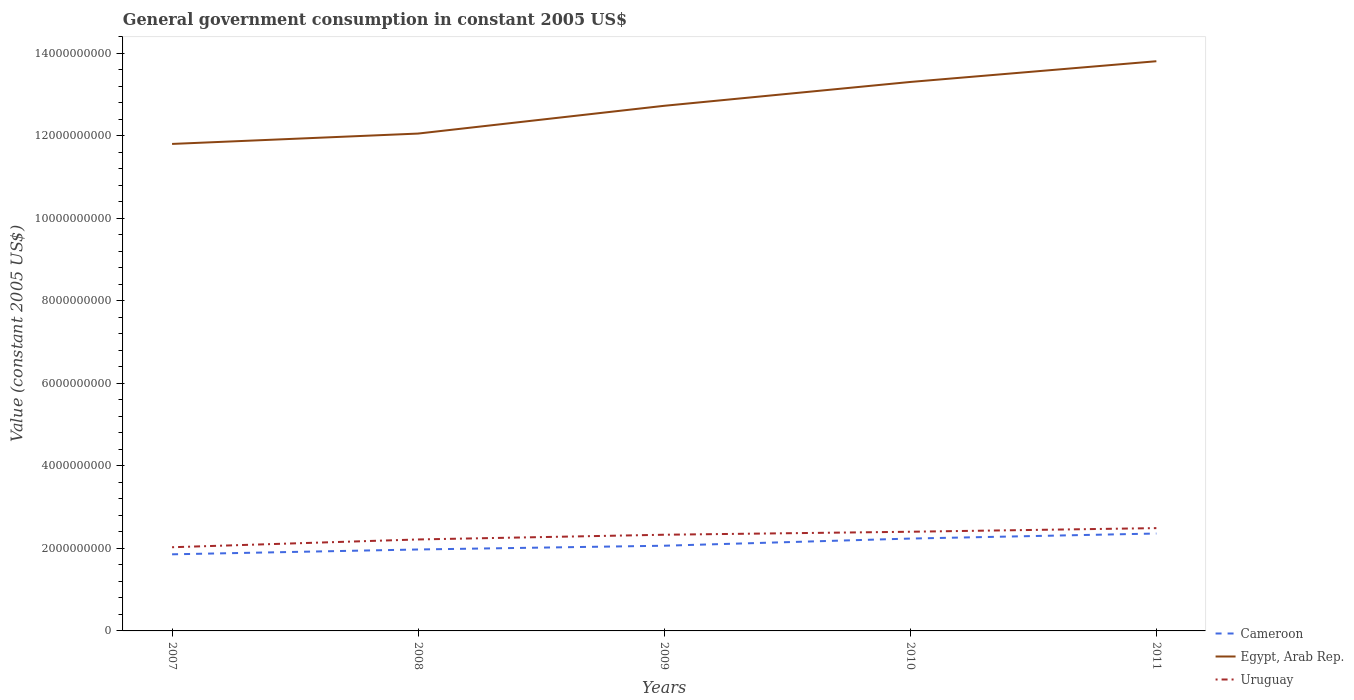Is the number of lines equal to the number of legend labels?
Your answer should be compact. Yes. Across all years, what is the maximum government conusmption in Egypt, Arab Rep.?
Make the answer very short. 1.18e+1. In which year was the government conusmption in Uruguay maximum?
Your answer should be compact. 2007. What is the total government conusmption in Uruguay in the graph?
Your answer should be very brief. -1.60e+08. What is the difference between the highest and the second highest government conusmption in Uruguay?
Make the answer very short. 4.63e+08. What is the difference between the highest and the lowest government conusmption in Uruguay?
Ensure brevity in your answer.  3. Does the graph contain grids?
Provide a short and direct response. No. Where does the legend appear in the graph?
Your response must be concise. Bottom right. What is the title of the graph?
Your answer should be compact. General government consumption in constant 2005 US$. Does "Morocco" appear as one of the legend labels in the graph?
Your answer should be compact. No. What is the label or title of the Y-axis?
Provide a succinct answer. Value (constant 2005 US$). What is the Value (constant 2005 US$) in Cameroon in 2007?
Provide a succinct answer. 1.86e+09. What is the Value (constant 2005 US$) of Egypt, Arab Rep. in 2007?
Provide a short and direct response. 1.18e+1. What is the Value (constant 2005 US$) in Uruguay in 2007?
Your answer should be compact. 2.03e+09. What is the Value (constant 2005 US$) of Cameroon in 2008?
Your answer should be compact. 1.97e+09. What is the Value (constant 2005 US$) of Egypt, Arab Rep. in 2008?
Offer a very short reply. 1.21e+1. What is the Value (constant 2005 US$) in Uruguay in 2008?
Your response must be concise. 2.22e+09. What is the Value (constant 2005 US$) in Cameroon in 2009?
Provide a short and direct response. 2.07e+09. What is the Value (constant 2005 US$) of Egypt, Arab Rep. in 2009?
Offer a terse response. 1.27e+1. What is the Value (constant 2005 US$) in Uruguay in 2009?
Your response must be concise. 2.33e+09. What is the Value (constant 2005 US$) of Cameroon in 2010?
Ensure brevity in your answer.  2.24e+09. What is the Value (constant 2005 US$) in Egypt, Arab Rep. in 2010?
Give a very brief answer. 1.33e+1. What is the Value (constant 2005 US$) of Uruguay in 2010?
Your answer should be compact. 2.40e+09. What is the Value (constant 2005 US$) of Cameroon in 2011?
Offer a terse response. 2.36e+09. What is the Value (constant 2005 US$) in Egypt, Arab Rep. in 2011?
Your answer should be very brief. 1.38e+1. What is the Value (constant 2005 US$) in Uruguay in 2011?
Keep it short and to the point. 2.49e+09. Across all years, what is the maximum Value (constant 2005 US$) of Cameroon?
Keep it short and to the point. 2.36e+09. Across all years, what is the maximum Value (constant 2005 US$) in Egypt, Arab Rep.?
Offer a terse response. 1.38e+1. Across all years, what is the maximum Value (constant 2005 US$) in Uruguay?
Provide a short and direct response. 2.49e+09. Across all years, what is the minimum Value (constant 2005 US$) of Cameroon?
Give a very brief answer. 1.86e+09. Across all years, what is the minimum Value (constant 2005 US$) in Egypt, Arab Rep.?
Your response must be concise. 1.18e+1. Across all years, what is the minimum Value (constant 2005 US$) in Uruguay?
Give a very brief answer. 2.03e+09. What is the total Value (constant 2005 US$) of Cameroon in the graph?
Offer a very short reply. 1.05e+1. What is the total Value (constant 2005 US$) in Egypt, Arab Rep. in the graph?
Your answer should be very brief. 6.37e+1. What is the total Value (constant 2005 US$) in Uruguay in the graph?
Keep it short and to the point. 1.15e+1. What is the difference between the Value (constant 2005 US$) of Cameroon in 2007 and that in 2008?
Provide a succinct answer. -1.17e+08. What is the difference between the Value (constant 2005 US$) in Egypt, Arab Rep. in 2007 and that in 2008?
Give a very brief answer. -2.51e+08. What is the difference between the Value (constant 2005 US$) of Uruguay in 2007 and that in 2008?
Give a very brief answer. -1.89e+08. What is the difference between the Value (constant 2005 US$) in Cameroon in 2007 and that in 2009?
Ensure brevity in your answer.  -2.09e+08. What is the difference between the Value (constant 2005 US$) of Egypt, Arab Rep. in 2007 and that in 2009?
Keep it short and to the point. -9.24e+08. What is the difference between the Value (constant 2005 US$) of Uruguay in 2007 and that in 2009?
Offer a terse response. -3.03e+08. What is the difference between the Value (constant 2005 US$) in Cameroon in 2007 and that in 2010?
Provide a succinct answer. -3.82e+08. What is the difference between the Value (constant 2005 US$) of Egypt, Arab Rep. in 2007 and that in 2010?
Your response must be concise. -1.50e+09. What is the difference between the Value (constant 2005 US$) in Uruguay in 2007 and that in 2010?
Give a very brief answer. -3.75e+08. What is the difference between the Value (constant 2005 US$) in Cameroon in 2007 and that in 2011?
Ensure brevity in your answer.  -5.04e+08. What is the difference between the Value (constant 2005 US$) of Egypt, Arab Rep. in 2007 and that in 2011?
Ensure brevity in your answer.  -2.00e+09. What is the difference between the Value (constant 2005 US$) in Uruguay in 2007 and that in 2011?
Provide a short and direct response. -4.63e+08. What is the difference between the Value (constant 2005 US$) in Cameroon in 2008 and that in 2009?
Your answer should be very brief. -9.13e+07. What is the difference between the Value (constant 2005 US$) in Egypt, Arab Rep. in 2008 and that in 2009?
Your response must be concise. -6.73e+08. What is the difference between the Value (constant 2005 US$) in Uruguay in 2008 and that in 2009?
Offer a very short reply. -1.14e+08. What is the difference between the Value (constant 2005 US$) in Cameroon in 2008 and that in 2010?
Keep it short and to the point. -2.65e+08. What is the difference between the Value (constant 2005 US$) in Egypt, Arab Rep. in 2008 and that in 2010?
Offer a terse response. -1.25e+09. What is the difference between the Value (constant 2005 US$) of Uruguay in 2008 and that in 2010?
Offer a very short reply. -1.87e+08. What is the difference between the Value (constant 2005 US$) in Cameroon in 2008 and that in 2011?
Offer a very short reply. -3.87e+08. What is the difference between the Value (constant 2005 US$) in Egypt, Arab Rep. in 2008 and that in 2011?
Ensure brevity in your answer.  -1.75e+09. What is the difference between the Value (constant 2005 US$) in Uruguay in 2008 and that in 2011?
Your answer should be very brief. -2.75e+08. What is the difference between the Value (constant 2005 US$) of Cameroon in 2009 and that in 2010?
Your answer should be very brief. -1.73e+08. What is the difference between the Value (constant 2005 US$) of Egypt, Arab Rep. in 2009 and that in 2010?
Give a very brief answer. -5.78e+08. What is the difference between the Value (constant 2005 US$) of Uruguay in 2009 and that in 2010?
Give a very brief answer. -7.25e+07. What is the difference between the Value (constant 2005 US$) in Cameroon in 2009 and that in 2011?
Keep it short and to the point. -2.96e+08. What is the difference between the Value (constant 2005 US$) in Egypt, Arab Rep. in 2009 and that in 2011?
Ensure brevity in your answer.  -1.08e+09. What is the difference between the Value (constant 2005 US$) of Uruguay in 2009 and that in 2011?
Provide a succinct answer. -1.60e+08. What is the difference between the Value (constant 2005 US$) in Cameroon in 2010 and that in 2011?
Offer a terse response. -1.22e+08. What is the difference between the Value (constant 2005 US$) in Egypt, Arab Rep. in 2010 and that in 2011?
Ensure brevity in your answer.  -5.03e+08. What is the difference between the Value (constant 2005 US$) of Uruguay in 2010 and that in 2011?
Give a very brief answer. -8.80e+07. What is the difference between the Value (constant 2005 US$) of Cameroon in 2007 and the Value (constant 2005 US$) of Egypt, Arab Rep. in 2008?
Offer a very short reply. -1.02e+1. What is the difference between the Value (constant 2005 US$) of Cameroon in 2007 and the Value (constant 2005 US$) of Uruguay in 2008?
Provide a succinct answer. -3.60e+08. What is the difference between the Value (constant 2005 US$) of Egypt, Arab Rep. in 2007 and the Value (constant 2005 US$) of Uruguay in 2008?
Provide a succinct answer. 9.59e+09. What is the difference between the Value (constant 2005 US$) in Cameroon in 2007 and the Value (constant 2005 US$) in Egypt, Arab Rep. in 2009?
Ensure brevity in your answer.  -1.09e+1. What is the difference between the Value (constant 2005 US$) of Cameroon in 2007 and the Value (constant 2005 US$) of Uruguay in 2009?
Keep it short and to the point. -4.75e+08. What is the difference between the Value (constant 2005 US$) of Egypt, Arab Rep. in 2007 and the Value (constant 2005 US$) of Uruguay in 2009?
Offer a very short reply. 9.47e+09. What is the difference between the Value (constant 2005 US$) in Cameroon in 2007 and the Value (constant 2005 US$) in Egypt, Arab Rep. in 2010?
Offer a terse response. -1.14e+1. What is the difference between the Value (constant 2005 US$) in Cameroon in 2007 and the Value (constant 2005 US$) in Uruguay in 2010?
Offer a terse response. -5.47e+08. What is the difference between the Value (constant 2005 US$) in Egypt, Arab Rep. in 2007 and the Value (constant 2005 US$) in Uruguay in 2010?
Keep it short and to the point. 9.40e+09. What is the difference between the Value (constant 2005 US$) in Cameroon in 2007 and the Value (constant 2005 US$) in Egypt, Arab Rep. in 2011?
Make the answer very short. -1.20e+1. What is the difference between the Value (constant 2005 US$) in Cameroon in 2007 and the Value (constant 2005 US$) in Uruguay in 2011?
Offer a terse response. -6.35e+08. What is the difference between the Value (constant 2005 US$) of Egypt, Arab Rep. in 2007 and the Value (constant 2005 US$) of Uruguay in 2011?
Your answer should be compact. 9.31e+09. What is the difference between the Value (constant 2005 US$) of Cameroon in 2008 and the Value (constant 2005 US$) of Egypt, Arab Rep. in 2009?
Offer a terse response. -1.08e+1. What is the difference between the Value (constant 2005 US$) in Cameroon in 2008 and the Value (constant 2005 US$) in Uruguay in 2009?
Your answer should be compact. -3.57e+08. What is the difference between the Value (constant 2005 US$) in Egypt, Arab Rep. in 2008 and the Value (constant 2005 US$) in Uruguay in 2009?
Provide a succinct answer. 9.72e+09. What is the difference between the Value (constant 2005 US$) of Cameroon in 2008 and the Value (constant 2005 US$) of Egypt, Arab Rep. in 2010?
Give a very brief answer. -1.13e+1. What is the difference between the Value (constant 2005 US$) in Cameroon in 2008 and the Value (constant 2005 US$) in Uruguay in 2010?
Provide a short and direct response. -4.30e+08. What is the difference between the Value (constant 2005 US$) of Egypt, Arab Rep. in 2008 and the Value (constant 2005 US$) of Uruguay in 2010?
Your answer should be compact. 9.65e+09. What is the difference between the Value (constant 2005 US$) in Cameroon in 2008 and the Value (constant 2005 US$) in Egypt, Arab Rep. in 2011?
Keep it short and to the point. -1.18e+1. What is the difference between the Value (constant 2005 US$) of Cameroon in 2008 and the Value (constant 2005 US$) of Uruguay in 2011?
Your answer should be compact. -5.18e+08. What is the difference between the Value (constant 2005 US$) of Egypt, Arab Rep. in 2008 and the Value (constant 2005 US$) of Uruguay in 2011?
Your answer should be compact. 9.56e+09. What is the difference between the Value (constant 2005 US$) in Cameroon in 2009 and the Value (constant 2005 US$) in Egypt, Arab Rep. in 2010?
Keep it short and to the point. -1.12e+1. What is the difference between the Value (constant 2005 US$) of Cameroon in 2009 and the Value (constant 2005 US$) of Uruguay in 2010?
Make the answer very short. -3.39e+08. What is the difference between the Value (constant 2005 US$) of Egypt, Arab Rep. in 2009 and the Value (constant 2005 US$) of Uruguay in 2010?
Offer a very short reply. 1.03e+1. What is the difference between the Value (constant 2005 US$) of Cameroon in 2009 and the Value (constant 2005 US$) of Egypt, Arab Rep. in 2011?
Offer a terse response. -1.17e+1. What is the difference between the Value (constant 2005 US$) of Cameroon in 2009 and the Value (constant 2005 US$) of Uruguay in 2011?
Make the answer very short. -4.27e+08. What is the difference between the Value (constant 2005 US$) of Egypt, Arab Rep. in 2009 and the Value (constant 2005 US$) of Uruguay in 2011?
Offer a very short reply. 1.02e+1. What is the difference between the Value (constant 2005 US$) in Cameroon in 2010 and the Value (constant 2005 US$) in Egypt, Arab Rep. in 2011?
Your response must be concise. -1.16e+1. What is the difference between the Value (constant 2005 US$) in Cameroon in 2010 and the Value (constant 2005 US$) in Uruguay in 2011?
Offer a very short reply. -2.53e+08. What is the difference between the Value (constant 2005 US$) of Egypt, Arab Rep. in 2010 and the Value (constant 2005 US$) of Uruguay in 2011?
Provide a short and direct response. 1.08e+1. What is the average Value (constant 2005 US$) of Cameroon per year?
Give a very brief answer. 2.10e+09. What is the average Value (constant 2005 US$) of Egypt, Arab Rep. per year?
Your answer should be very brief. 1.27e+1. What is the average Value (constant 2005 US$) in Uruguay per year?
Offer a very short reply. 2.29e+09. In the year 2007, what is the difference between the Value (constant 2005 US$) in Cameroon and Value (constant 2005 US$) in Egypt, Arab Rep.?
Keep it short and to the point. -9.95e+09. In the year 2007, what is the difference between the Value (constant 2005 US$) of Cameroon and Value (constant 2005 US$) of Uruguay?
Offer a terse response. -1.72e+08. In the year 2007, what is the difference between the Value (constant 2005 US$) in Egypt, Arab Rep. and Value (constant 2005 US$) in Uruguay?
Provide a short and direct response. 9.77e+09. In the year 2008, what is the difference between the Value (constant 2005 US$) of Cameroon and Value (constant 2005 US$) of Egypt, Arab Rep.?
Your response must be concise. -1.01e+1. In the year 2008, what is the difference between the Value (constant 2005 US$) of Cameroon and Value (constant 2005 US$) of Uruguay?
Your answer should be compact. -2.43e+08. In the year 2008, what is the difference between the Value (constant 2005 US$) of Egypt, Arab Rep. and Value (constant 2005 US$) of Uruguay?
Your response must be concise. 9.84e+09. In the year 2009, what is the difference between the Value (constant 2005 US$) in Cameroon and Value (constant 2005 US$) in Egypt, Arab Rep.?
Provide a short and direct response. -1.07e+1. In the year 2009, what is the difference between the Value (constant 2005 US$) of Cameroon and Value (constant 2005 US$) of Uruguay?
Your response must be concise. -2.66e+08. In the year 2009, what is the difference between the Value (constant 2005 US$) of Egypt, Arab Rep. and Value (constant 2005 US$) of Uruguay?
Offer a very short reply. 1.04e+1. In the year 2010, what is the difference between the Value (constant 2005 US$) of Cameroon and Value (constant 2005 US$) of Egypt, Arab Rep.?
Offer a very short reply. -1.11e+1. In the year 2010, what is the difference between the Value (constant 2005 US$) in Cameroon and Value (constant 2005 US$) in Uruguay?
Offer a very short reply. -1.65e+08. In the year 2010, what is the difference between the Value (constant 2005 US$) in Egypt, Arab Rep. and Value (constant 2005 US$) in Uruguay?
Give a very brief answer. 1.09e+1. In the year 2011, what is the difference between the Value (constant 2005 US$) of Cameroon and Value (constant 2005 US$) of Egypt, Arab Rep.?
Make the answer very short. -1.14e+1. In the year 2011, what is the difference between the Value (constant 2005 US$) of Cameroon and Value (constant 2005 US$) of Uruguay?
Ensure brevity in your answer.  -1.31e+08. In the year 2011, what is the difference between the Value (constant 2005 US$) in Egypt, Arab Rep. and Value (constant 2005 US$) in Uruguay?
Your answer should be compact. 1.13e+1. What is the ratio of the Value (constant 2005 US$) in Cameroon in 2007 to that in 2008?
Offer a very short reply. 0.94. What is the ratio of the Value (constant 2005 US$) of Egypt, Arab Rep. in 2007 to that in 2008?
Keep it short and to the point. 0.98. What is the ratio of the Value (constant 2005 US$) in Uruguay in 2007 to that in 2008?
Offer a terse response. 0.91. What is the ratio of the Value (constant 2005 US$) of Cameroon in 2007 to that in 2009?
Offer a very short reply. 0.9. What is the ratio of the Value (constant 2005 US$) of Egypt, Arab Rep. in 2007 to that in 2009?
Make the answer very short. 0.93. What is the ratio of the Value (constant 2005 US$) in Uruguay in 2007 to that in 2009?
Give a very brief answer. 0.87. What is the ratio of the Value (constant 2005 US$) in Cameroon in 2007 to that in 2010?
Provide a short and direct response. 0.83. What is the ratio of the Value (constant 2005 US$) of Egypt, Arab Rep. in 2007 to that in 2010?
Keep it short and to the point. 0.89. What is the ratio of the Value (constant 2005 US$) in Uruguay in 2007 to that in 2010?
Your response must be concise. 0.84. What is the ratio of the Value (constant 2005 US$) of Cameroon in 2007 to that in 2011?
Keep it short and to the point. 0.79. What is the ratio of the Value (constant 2005 US$) in Egypt, Arab Rep. in 2007 to that in 2011?
Provide a short and direct response. 0.85. What is the ratio of the Value (constant 2005 US$) in Uruguay in 2007 to that in 2011?
Provide a short and direct response. 0.81. What is the ratio of the Value (constant 2005 US$) in Cameroon in 2008 to that in 2009?
Provide a succinct answer. 0.96. What is the ratio of the Value (constant 2005 US$) of Egypt, Arab Rep. in 2008 to that in 2009?
Your answer should be compact. 0.95. What is the ratio of the Value (constant 2005 US$) in Uruguay in 2008 to that in 2009?
Keep it short and to the point. 0.95. What is the ratio of the Value (constant 2005 US$) of Cameroon in 2008 to that in 2010?
Give a very brief answer. 0.88. What is the ratio of the Value (constant 2005 US$) of Egypt, Arab Rep. in 2008 to that in 2010?
Offer a terse response. 0.91. What is the ratio of the Value (constant 2005 US$) of Uruguay in 2008 to that in 2010?
Give a very brief answer. 0.92. What is the ratio of the Value (constant 2005 US$) of Cameroon in 2008 to that in 2011?
Give a very brief answer. 0.84. What is the ratio of the Value (constant 2005 US$) of Egypt, Arab Rep. in 2008 to that in 2011?
Provide a succinct answer. 0.87. What is the ratio of the Value (constant 2005 US$) in Uruguay in 2008 to that in 2011?
Keep it short and to the point. 0.89. What is the ratio of the Value (constant 2005 US$) in Cameroon in 2009 to that in 2010?
Provide a succinct answer. 0.92. What is the ratio of the Value (constant 2005 US$) in Egypt, Arab Rep. in 2009 to that in 2010?
Your answer should be very brief. 0.96. What is the ratio of the Value (constant 2005 US$) of Uruguay in 2009 to that in 2010?
Provide a short and direct response. 0.97. What is the ratio of the Value (constant 2005 US$) in Cameroon in 2009 to that in 2011?
Your answer should be very brief. 0.87. What is the ratio of the Value (constant 2005 US$) in Egypt, Arab Rep. in 2009 to that in 2011?
Your response must be concise. 0.92. What is the ratio of the Value (constant 2005 US$) of Uruguay in 2009 to that in 2011?
Keep it short and to the point. 0.94. What is the ratio of the Value (constant 2005 US$) in Cameroon in 2010 to that in 2011?
Make the answer very short. 0.95. What is the ratio of the Value (constant 2005 US$) in Egypt, Arab Rep. in 2010 to that in 2011?
Your response must be concise. 0.96. What is the ratio of the Value (constant 2005 US$) in Uruguay in 2010 to that in 2011?
Ensure brevity in your answer.  0.96. What is the difference between the highest and the second highest Value (constant 2005 US$) of Cameroon?
Make the answer very short. 1.22e+08. What is the difference between the highest and the second highest Value (constant 2005 US$) in Egypt, Arab Rep.?
Provide a succinct answer. 5.03e+08. What is the difference between the highest and the second highest Value (constant 2005 US$) in Uruguay?
Your response must be concise. 8.80e+07. What is the difference between the highest and the lowest Value (constant 2005 US$) of Cameroon?
Provide a succinct answer. 5.04e+08. What is the difference between the highest and the lowest Value (constant 2005 US$) in Egypt, Arab Rep.?
Provide a succinct answer. 2.00e+09. What is the difference between the highest and the lowest Value (constant 2005 US$) of Uruguay?
Ensure brevity in your answer.  4.63e+08. 